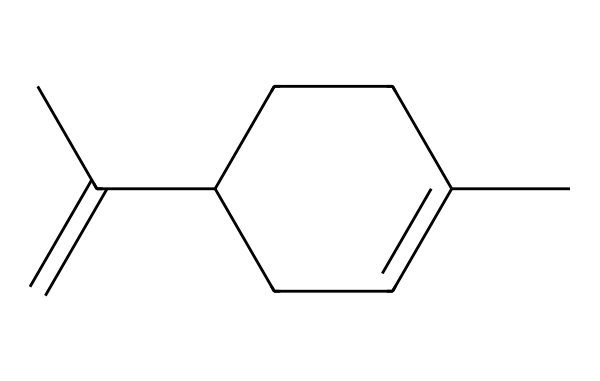What is the name of the chemical represented by this SMILES? The SMILES representation given corresponds to the molecular structure of limonene, which is a common monoterpene found in citrus fruits.
Answer: limonene How many carbon atoms are in the chemical structure? By analyzing the structure based on the SMILES, we see a chain of 10 carbon atoms, as indicated by the multiple carbon-containing groups throughout the structure.
Answer: 10 What type of chemical structure is limonene classified as? Limonene is a monoterpene, which is a type of terpene made up of two isoprene units, reflected by its molecular formula and structure.
Answer: monoterpene How many double bonds are present in this chemical structure? Looking at the structure, there is one double bond located in the carbon chain, specifically between the carbon atoms in the cyclohexene part of the structure.
Answer: 1 What functional group is present in limonene due to its structure? The presence of a double bond in limonene indicates that it contains an alkene functional group, which characterizes its reactivity.
Answer: alkene What is the hybridization of the carbon atoms involved in the double bond? The carbon atoms involved in the double bond are sp² hybridized, as they are part of a planar structure with one pi bond.
Answer: sp² Is limonene chiral, and if so, how many chiral centers are there? Yes, limonene is chiral because it has one chiral center in the structure, where the carbon atom is bonded to four different groups.
Answer: 1 